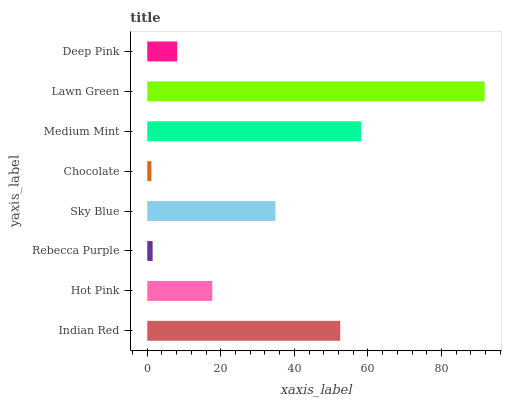Is Chocolate the minimum?
Answer yes or no. Yes. Is Lawn Green the maximum?
Answer yes or no. Yes. Is Hot Pink the minimum?
Answer yes or no. No. Is Hot Pink the maximum?
Answer yes or no. No. Is Indian Red greater than Hot Pink?
Answer yes or no. Yes. Is Hot Pink less than Indian Red?
Answer yes or no. Yes. Is Hot Pink greater than Indian Red?
Answer yes or no. No. Is Indian Red less than Hot Pink?
Answer yes or no. No. Is Sky Blue the high median?
Answer yes or no. Yes. Is Hot Pink the low median?
Answer yes or no. Yes. Is Deep Pink the high median?
Answer yes or no. No. Is Rebecca Purple the low median?
Answer yes or no. No. 